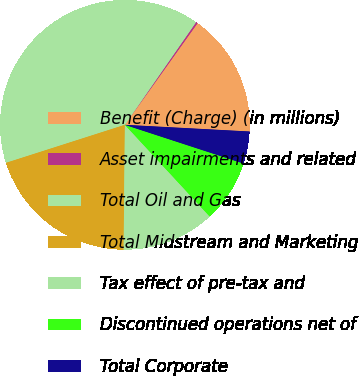<chart> <loc_0><loc_0><loc_500><loc_500><pie_chart><fcel>Benefit (Charge) (in millions)<fcel>Asset impairments and related<fcel>Total Oil and Gas<fcel>Total Midstream and Marketing<fcel>Tax effect of pre-tax and<fcel>Discontinued operations net of<fcel>Total Corporate<nl><fcel>15.97%<fcel>0.23%<fcel>39.58%<fcel>19.91%<fcel>12.04%<fcel>8.1%<fcel>4.17%<nl></chart> 